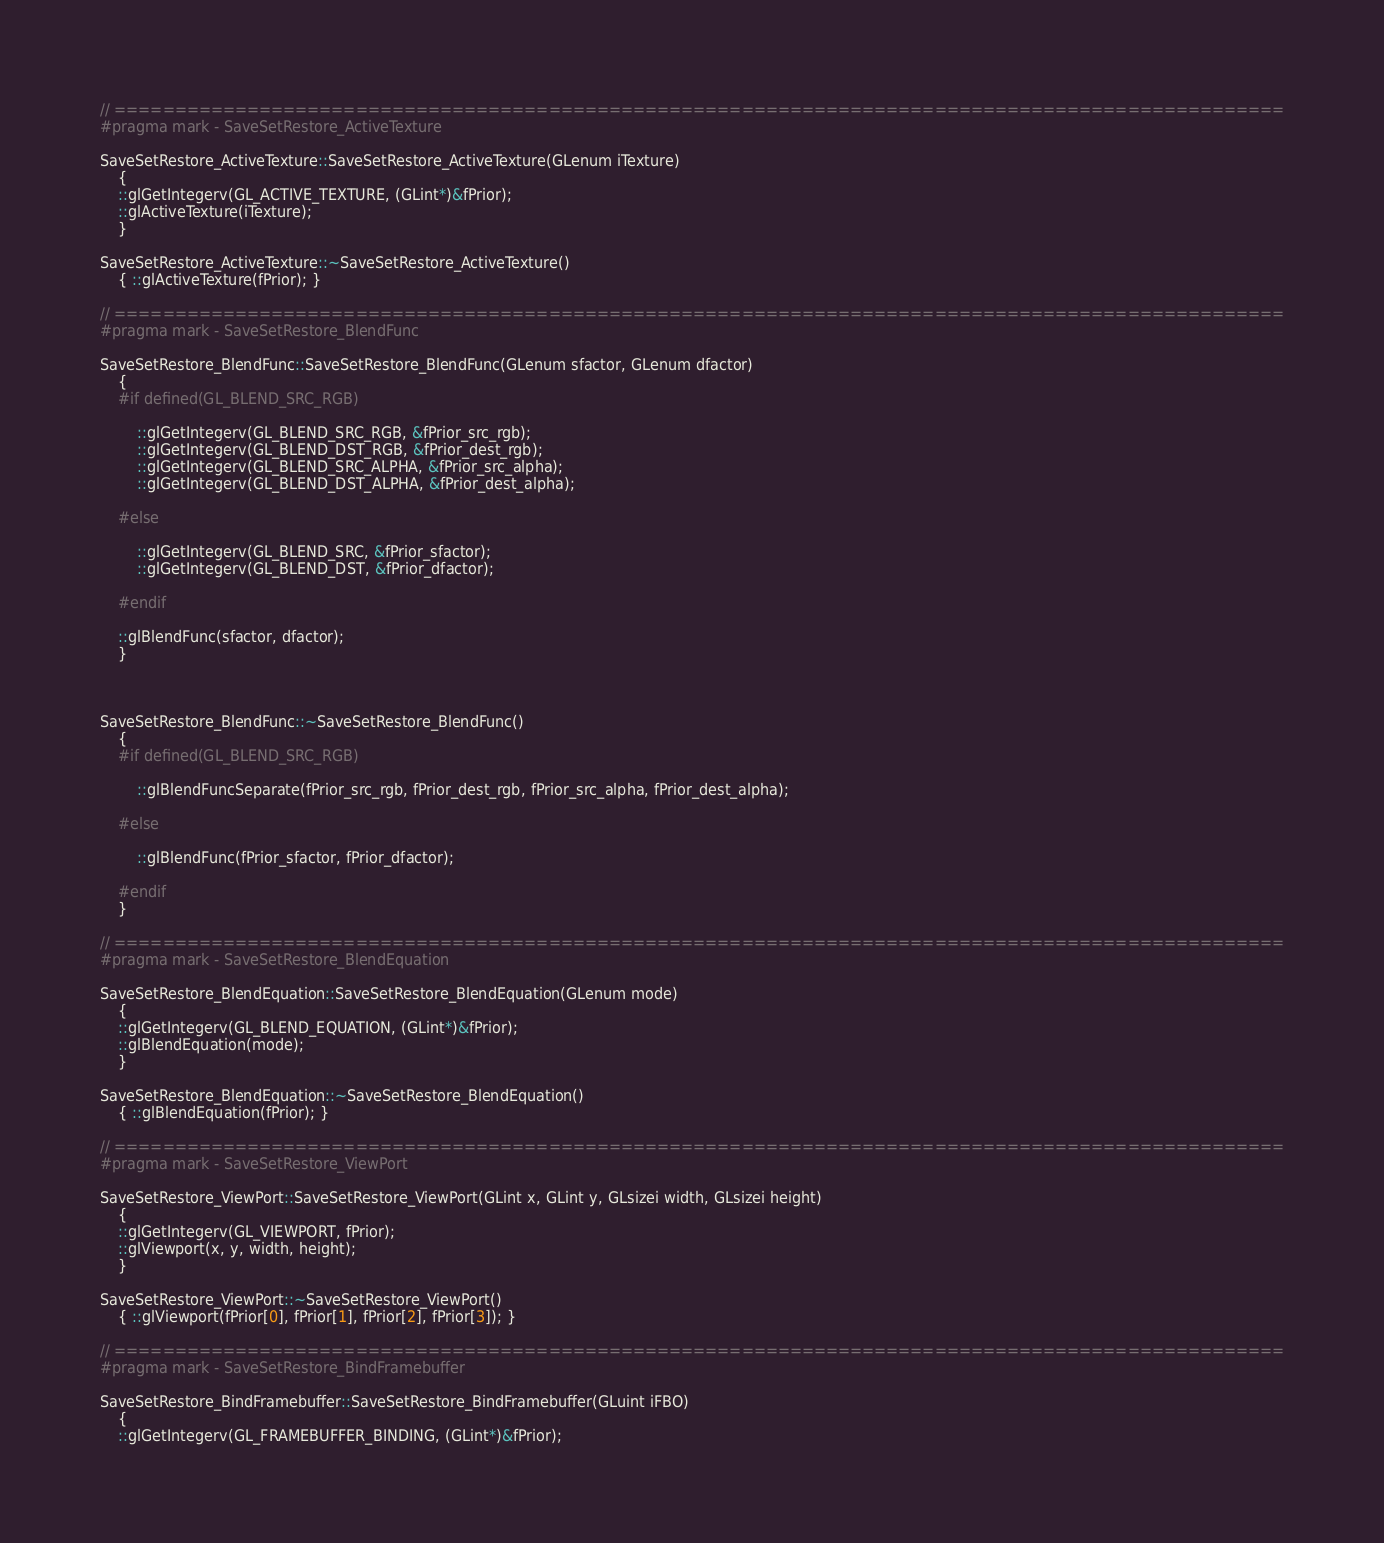<code> <loc_0><loc_0><loc_500><loc_500><_C++_>// =================================================================================================
#pragma mark - SaveSetRestore_ActiveTexture

SaveSetRestore_ActiveTexture::SaveSetRestore_ActiveTexture(GLenum iTexture)
	{
	::glGetIntegerv(GL_ACTIVE_TEXTURE, (GLint*)&fPrior);
	::glActiveTexture(iTexture);
	}

SaveSetRestore_ActiveTexture::~SaveSetRestore_ActiveTexture()
	{ ::glActiveTexture(fPrior); }

// =================================================================================================
#pragma mark - SaveSetRestore_BlendFunc

SaveSetRestore_BlendFunc::SaveSetRestore_BlendFunc(GLenum sfactor, GLenum dfactor)
	{
	#if defined(GL_BLEND_SRC_RGB)

		::glGetIntegerv(GL_BLEND_SRC_RGB, &fPrior_src_rgb);
		::glGetIntegerv(GL_BLEND_DST_RGB, &fPrior_dest_rgb);
		::glGetIntegerv(GL_BLEND_SRC_ALPHA, &fPrior_src_alpha);
		::glGetIntegerv(GL_BLEND_DST_ALPHA, &fPrior_dest_alpha);

	#else

		::glGetIntegerv(GL_BLEND_SRC, &fPrior_sfactor);
		::glGetIntegerv(GL_BLEND_DST, &fPrior_dfactor);

	#endif

	::glBlendFunc(sfactor, dfactor);
	}



SaveSetRestore_BlendFunc::~SaveSetRestore_BlendFunc()
	{
	#if defined(GL_BLEND_SRC_RGB)

		::glBlendFuncSeparate(fPrior_src_rgb, fPrior_dest_rgb, fPrior_src_alpha, fPrior_dest_alpha);

	#else

		::glBlendFunc(fPrior_sfactor, fPrior_dfactor);

	#endif
	}

// =================================================================================================
#pragma mark - SaveSetRestore_BlendEquation

SaveSetRestore_BlendEquation::SaveSetRestore_BlendEquation(GLenum mode)
	{
	::glGetIntegerv(GL_BLEND_EQUATION, (GLint*)&fPrior);
	::glBlendEquation(mode);
	}

SaveSetRestore_BlendEquation::~SaveSetRestore_BlendEquation()
	{ ::glBlendEquation(fPrior); }

// =================================================================================================
#pragma mark - SaveSetRestore_ViewPort

SaveSetRestore_ViewPort::SaveSetRestore_ViewPort(GLint x, GLint y, GLsizei width, GLsizei height)
	{
	::glGetIntegerv(GL_VIEWPORT, fPrior);
	::glViewport(x, y, width, height);
	}

SaveSetRestore_ViewPort::~SaveSetRestore_ViewPort()
	{ ::glViewport(fPrior[0], fPrior[1], fPrior[2], fPrior[3]); }

// =================================================================================================
#pragma mark - SaveSetRestore_BindFramebuffer

SaveSetRestore_BindFramebuffer::SaveSetRestore_BindFramebuffer(GLuint iFBO)
	{
	::glGetIntegerv(GL_FRAMEBUFFER_BINDING, (GLint*)&fPrior);</code> 